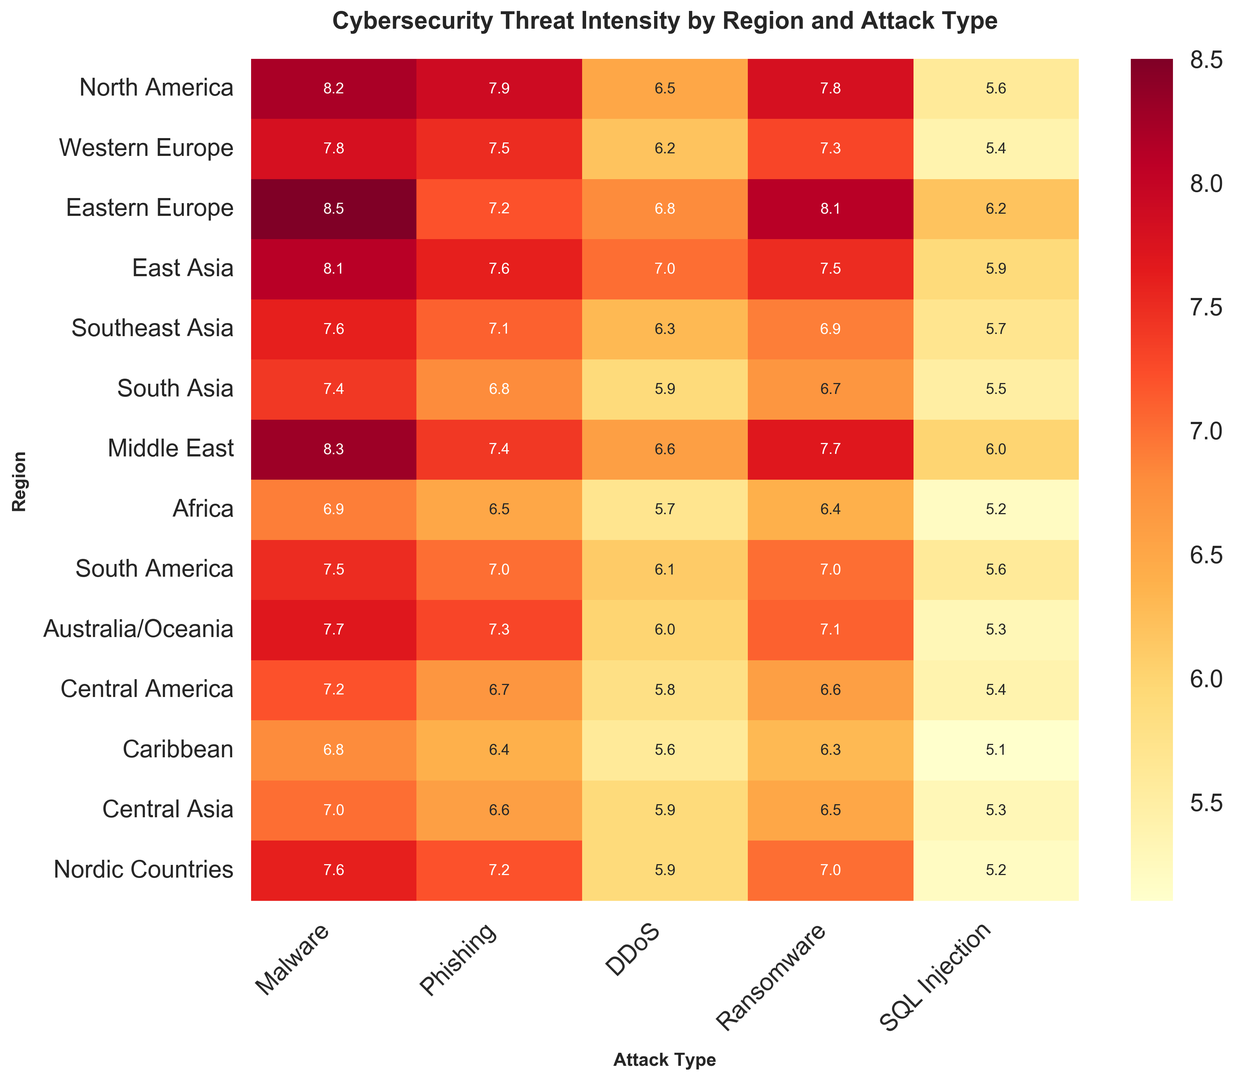Which region has the highest intensity of Malware attacks? The figure shows the intensity of Malware attacks in various regions. North America, Eastern Europe, and the Middle East have high intensities. By comparing the values, Eastern Europe has the highest value at 8.5.
Answer: Eastern Europe Which attack type has the lowest intensity in Australia/Oceania? The figure shows the intensities of different attack types across regions. For Australia/Oceania, the values are compared. The lowest value is for the "DDoS" category at 6.0.
Answer: DDoS What's the average intensity of Ransomware attacks in Western Europe, Southeast Asia, and South America? The figure shows the intensity of Ransomware attacks in various regions. For Western Europe, Southeast Asia, and South America, the values are 7.3, 6.9, and 7.0 respectively. Calculating the average: (7.3 + 6.9 + 7.0) / 3 = 7.067.
Answer: 7.067 Which region has the lowest overall threat intensity for all types of attacks combined? We need to sum the threat intensities for all attack types in each region and compare. By summing the intensities and comparing, the Caribbean region has the lowest combined value.
Answer: Caribbean How does the intensity of Phishing in North America compare to that in South Asia? The figure shows the intensity of Phishing attacks. The value for North America is 7.9, and for South Asia, it is 6.8. By comparing, Phishing is more intense in North America.
Answer: Higher in North America Among East Asia and Middle East, which region experiences higher DDoS attack intensity and by how much? The figure shows DDoS attack intensities for East Asia and Middle East. The values are 7.0 for East Asia and 6.6 for Middle East. The difference is 7.0 - 6.6 = 0.4.
Answer: East Asia by 0.4 What is the range of SQL Injection attack intensities across all regions? To find the range, first identify the minimum and maximum values for SQL Injection attacks. The minimum is 5.1 (Caribbean) and the maximum is 6.2 (Eastern Europe). The range is 6.2 - 5.1 = 1.1.
Answer: 1.1 Compare the average intensities of all attack types in North America and Eastern Europe. Which region has a higher average? Calculate the average intensities for North America (8.2+7.9+6.5+7.8+5.6)/5 = 7.2, and for Eastern Europe (8.5+7.2+6.8+8.1+6.2)/5 = 7.36. Comparing the averages, Eastern Europe has a higher average.
Answer: Eastern Europe Which regions have an intensity greater than 7 for all types of attacks? Identify regions where the intensity for each attack type is greater than 7. Only North America and Middle East show values consistently above 7 across all attack types.
Answer: North America, Middle East Which attack type has the most consistent intensity across all regions, and what is its standard deviation? Calculate the standard deviation for each attack type's intensities across all regions. Comparing all standard deviations, "Phishing" has the most consistent values, with the least variation from the computed standard deviation ≈ 0.48.
Answer: Phishing 